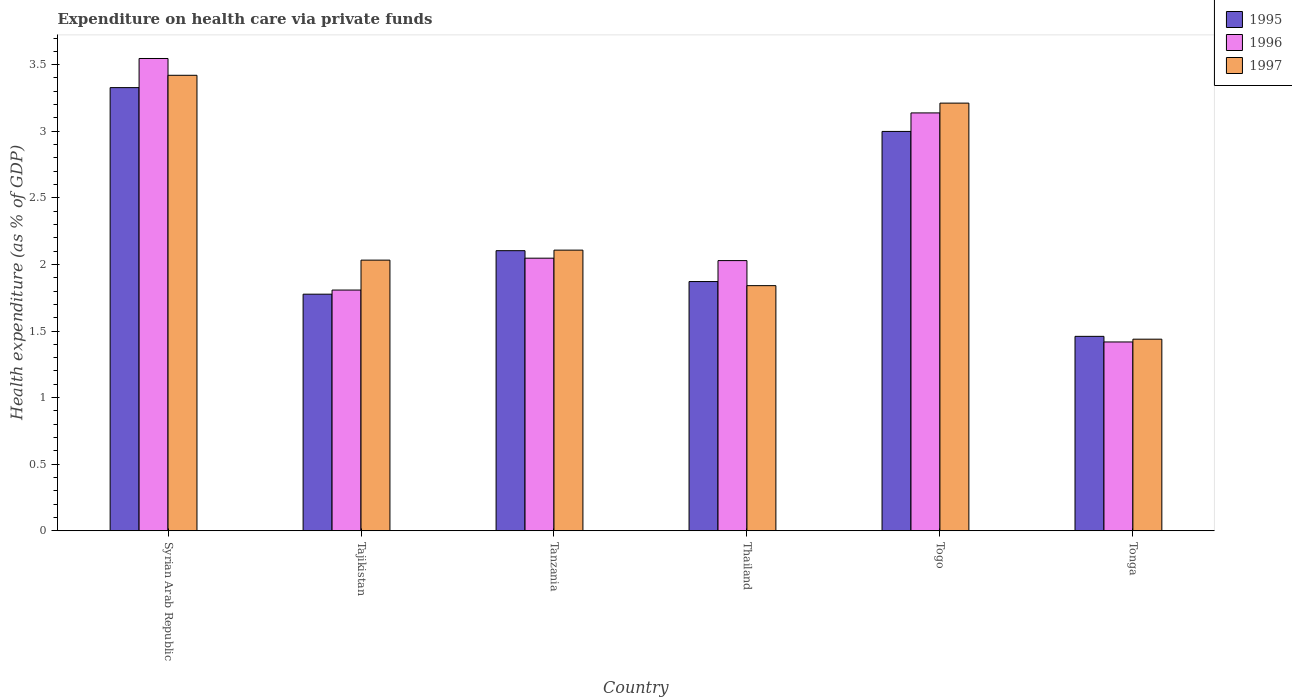Are the number of bars on each tick of the X-axis equal?
Your response must be concise. Yes. What is the label of the 2nd group of bars from the left?
Your response must be concise. Tajikistan. In how many cases, is the number of bars for a given country not equal to the number of legend labels?
Keep it short and to the point. 0. What is the expenditure made on health care in 1995 in Thailand?
Offer a very short reply. 1.87. Across all countries, what is the maximum expenditure made on health care in 1997?
Keep it short and to the point. 3.42. Across all countries, what is the minimum expenditure made on health care in 1995?
Your response must be concise. 1.46. In which country was the expenditure made on health care in 1995 maximum?
Provide a succinct answer. Syrian Arab Republic. In which country was the expenditure made on health care in 1995 minimum?
Offer a very short reply. Tonga. What is the total expenditure made on health care in 1995 in the graph?
Provide a succinct answer. 13.54. What is the difference between the expenditure made on health care in 1996 in Tanzania and that in Tonga?
Give a very brief answer. 0.63. What is the difference between the expenditure made on health care in 1995 in Tonga and the expenditure made on health care in 1996 in Togo?
Keep it short and to the point. -1.68. What is the average expenditure made on health care in 1996 per country?
Make the answer very short. 2.33. What is the difference between the expenditure made on health care of/in 1996 and expenditure made on health care of/in 1997 in Thailand?
Your answer should be very brief. 0.19. In how many countries, is the expenditure made on health care in 1996 greater than 2.6 %?
Provide a succinct answer. 2. What is the ratio of the expenditure made on health care in 1995 in Syrian Arab Republic to that in Tajikistan?
Your response must be concise. 1.87. What is the difference between the highest and the second highest expenditure made on health care in 1995?
Provide a short and direct response. -0.33. What is the difference between the highest and the lowest expenditure made on health care in 1995?
Give a very brief answer. 1.87. In how many countries, is the expenditure made on health care in 1997 greater than the average expenditure made on health care in 1997 taken over all countries?
Keep it short and to the point. 2. Is the sum of the expenditure made on health care in 1997 in Syrian Arab Republic and Togo greater than the maximum expenditure made on health care in 1995 across all countries?
Provide a succinct answer. Yes. What does the 2nd bar from the right in Tonga represents?
Your response must be concise. 1996. Is it the case that in every country, the sum of the expenditure made on health care in 1995 and expenditure made on health care in 1997 is greater than the expenditure made on health care in 1996?
Provide a succinct answer. Yes. How many bars are there?
Ensure brevity in your answer.  18. How many countries are there in the graph?
Offer a very short reply. 6. Are the values on the major ticks of Y-axis written in scientific E-notation?
Ensure brevity in your answer.  No. Does the graph contain any zero values?
Offer a very short reply. No. Does the graph contain grids?
Your answer should be compact. No. How many legend labels are there?
Give a very brief answer. 3. How are the legend labels stacked?
Provide a short and direct response. Vertical. What is the title of the graph?
Provide a succinct answer. Expenditure on health care via private funds. What is the label or title of the Y-axis?
Ensure brevity in your answer.  Health expenditure (as % of GDP). What is the Health expenditure (as % of GDP) of 1995 in Syrian Arab Republic?
Keep it short and to the point. 3.33. What is the Health expenditure (as % of GDP) of 1996 in Syrian Arab Republic?
Give a very brief answer. 3.55. What is the Health expenditure (as % of GDP) of 1997 in Syrian Arab Republic?
Offer a terse response. 3.42. What is the Health expenditure (as % of GDP) in 1995 in Tajikistan?
Offer a terse response. 1.78. What is the Health expenditure (as % of GDP) in 1996 in Tajikistan?
Your answer should be very brief. 1.81. What is the Health expenditure (as % of GDP) of 1997 in Tajikistan?
Provide a succinct answer. 2.03. What is the Health expenditure (as % of GDP) in 1995 in Tanzania?
Ensure brevity in your answer.  2.1. What is the Health expenditure (as % of GDP) in 1996 in Tanzania?
Keep it short and to the point. 2.05. What is the Health expenditure (as % of GDP) in 1997 in Tanzania?
Offer a very short reply. 2.11. What is the Health expenditure (as % of GDP) of 1995 in Thailand?
Provide a short and direct response. 1.87. What is the Health expenditure (as % of GDP) of 1996 in Thailand?
Your answer should be very brief. 2.03. What is the Health expenditure (as % of GDP) of 1997 in Thailand?
Ensure brevity in your answer.  1.84. What is the Health expenditure (as % of GDP) in 1995 in Togo?
Offer a terse response. 3. What is the Health expenditure (as % of GDP) in 1996 in Togo?
Make the answer very short. 3.14. What is the Health expenditure (as % of GDP) of 1997 in Togo?
Ensure brevity in your answer.  3.21. What is the Health expenditure (as % of GDP) in 1995 in Tonga?
Your answer should be compact. 1.46. What is the Health expenditure (as % of GDP) of 1996 in Tonga?
Offer a very short reply. 1.42. What is the Health expenditure (as % of GDP) in 1997 in Tonga?
Your answer should be compact. 1.44. Across all countries, what is the maximum Health expenditure (as % of GDP) of 1995?
Give a very brief answer. 3.33. Across all countries, what is the maximum Health expenditure (as % of GDP) of 1996?
Your answer should be very brief. 3.55. Across all countries, what is the maximum Health expenditure (as % of GDP) of 1997?
Give a very brief answer. 3.42. Across all countries, what is the minimum Health expenditure (as % of GDP) in 1995?
Ensure brevity in your answer.  1.46. Across all countries, what is the minimum Health expenditure (as % of GDP) in 1996?
Your response must be concise. 1.42. Across all countries, what is the minimum Health expenditure (as % of GDP) of 1997?
Ensure brevity in your answer.  1.44. What is the total Health expenditure (as % of GDP) of 1995 in the graph?
Give a very brief answer. 13.54. What is the total Health expenditure (as % of GDP) in 1996 in the graph?
Provide a succinct answer. 13.99. What is the total Health expenditure (as % of GDP) of 1997 in the graph?
Keep it short and to the point. 14.05. What is the difference between the Health expenditure (as % of GDP) in 1995 in Syrian Arab Republic and that in Tajikistan?
Your answer should be compact. 1.55. What is the difference between the Health expenditure (as % of GDP) of 1996 in Syrian Arab Republic and that in Tajikistan?
Your response must be concise. 1.74. What is the difference between the Health expenditure (as % of GDP) of 1997 in Syrian Arab Republic and that in Tajikistan?
Provide a succinct answer. 1.39. What is the difference between the Health expenditure (as % of GDP) of 1995 in Syrian Arab Republic and that in Tanzania?
Give a very brief answer. 1.22. What is the difference between the Health expenditure (as % of GDP) in 1996 in Syrian Arab Republic and that in Tanzania?
Make the answer very short. 1.5. What is the difference between the Health expenditure (as % of GDP) in 1997 in Syrian Arab Republic and that in Tanzania?
Offer a terse response. 1.31. What is the difference between the Health expenditure (as % of GDP) of 1995 in Syrian Arab Republic and that in Thailand?
Give a very brief answer. 1.46. What is the difference between the Health expenditure (as % of GDP) in 1996 in Syrian Arab Republic and that in Thailand?
Offer a terse response. 1.52. What is the difference between the Health expenditure (as % of GDP) in 1997 in Syrian Arab Republic and that in Thailand?
Your answer should be very brief. 1.58. What is the difference between the Health expenditure (as % of GDP) of 1995 in Syrian Arab Republic and that in Togo?
Make the answer very short. 0.33. What is the difference between the Health expenditure (as % of GDP) of 1996 in Syrian Arab Republic and that in Togo?
Ensure brevity in your answer.  0.41. What is the difference between the Health expenditure (as % of GDP) of 1997 in Syrian Arab Republic and that in Togo?
Provide a succinct answer. 0.21. What is the difference between the Health expenditure (as % of GDP) in 1995 in Syrian Arab Republic and that in Tonga?
Provide a short and direct response. 1.87. What is the difference between the Health expenditure (as % of GDP) in 1996 in Syrian Arab Republic and that in Tonga?
Provide a succinct answer. 2.13. What is the difference between the Health expenditure (as % of GDP) of 1997 in Syrian Arab Republic and that in Tonga?
Keep it short and to the point. 1.98. What is the difference between the Health expenditure (as % of GDP) in 1995 in Tajikistan and that in Tanzania?
Offer a terse response. -0.33. What is the difference between the Health expenditure (as % of GDP) in 1996 in Tajikistan and that in Tanzania?
Provide a succinct answer. -0.24. What is the difference between the Health expenditure (as % of GDP) of 1997 in Tajikistan and that in Tanzania?
Ensure brevity in your answer.  -0.08. What is the difference between the Health expenditure (as % of GDP) in 1995 in Tajikistan and that in Thailand?
Provide a short and direct response. -0.09. What is the difference between the Health expenditure (as % of GDP) of 1996 in Tajikistan and that in Thailand?
Your answer should be compact. -0.22. What is the difference between the Health expenditure (as % of GDP) in 1997 in Tajikistan and that in Thailand?
Offer a very short reply. 0.19. What is the difference between the Health expenditure (as % of GDP) in 1995 in Tajikistan and that in Togo?
Make the answer very short. -1.22. What is the difference between the Health expenditure (as % of GDP) in 1996 in Tajikistan and that in Togo?
Your answer should be very brief. -1.33. What is the difference between the Health expenditure (as % of GDP) in 1997 in Tajikistan and that in Togo?
Ensure brevity in your answer.  -1.18. What is the difference between the Health expenditure (as % of GDP) of 1995 in Tajikistan and that in Tonga?
Provide a short and direct response. 0.32. What is the difference between the Health expenditure (as % of GDP) in 1996 in Tajikistan and that in Tonga?
Your answer should be very brief. 0.39. What is the difference between the Health expenditure (as % of GDP) of 1997 in Tajikistan and that in Tonga?
Your answer should be compact. 0.59. What is the difference between the Health expenditure (as % of GDP) in 1995 in Tanzania and that in Thailand?
Provide a short and direct response. 0.23. What is the difference between the Health expenditure (as % of GDP) of 1996 in Tanzania and that in Thailand?
Make the answer very short. 0.02. What is the difference between the Health expenditure (as % of GDP) of 1997 in Tanzania and that in Thailand?
Your answer should be very brief. 0.27. What is the difference between the Health expenditure (as % of GDP) in 1995 in Tanzania and that in Togo?
Keep it short and to the point. -0.9. What is the difference between the Health expenditure (as % of GDP) in 1996 in Tanzania and that in Togo?
Ensure brevity in your answer.  -1.09. What is the difference between the Health expenditure (as % of GDP) in 1997 in Tanzania and that in Togo?
Provide a succinct answer. -1.1. What is the difference between the Health expenditure (as % of GDP) of 1995 in Tanzania and that in Tonga?
Keep it short and to the point. 0.64. What is the difference between the Health expenditure (as % of GDP) in 1996 in Tanzania and that in Tonga?
Provide a short and direct response. 0.63. What is the difference between the Health expenditure (as % of GDP) in 1997 in Tanzania and that in Tonga?
Offer a very short reply. 0.67. What is the difference between the Health expenditure (as % of GDP) in 1995 in Thailand and that in Togo?
Make the answer very short. -1.13. What is the difference between the Health expenditure (as % of GDP) in 1996 in Thailand and that in Togo?
Your answer should be very brief. -1.11. What is the difference between the Health expenditure (as % of GDP) in 1997 in Thailand and that in Togo?
Make the answer very short. -1.37. What is the difference between the Health expenditure (as % of GDP) in 1995 in Thailand and that in Tonga?
Provide a short and direct response. 0.41. What is the difference between the Health expenditure (as % of GDP) in 1996 in Thailand and that in Tonga?
Make the answer very short. 0.61. What is the difference between the Health expenditure (as % of GDP) in 1997 in Thailand and that in Tonga?
Ensure brevity in your answer.  0.4. What is the difference between the Health expenditure (as % of GDP) in 1995 in Togo and that in Tonga?
Keep it short and to the point. 1.54. What is the difference between the Health expenditure (as % of GDP) in 1996 in Togo and that in Tonga?
Make the answer very short. 1.72. What is the difference between the Health expenditure (as % of GDP) of 1997 in Togo and that in Tonga?
Your answer should be compact. 1.77. What is the difference between the Health expenditure (as % of GDP) in 1995 in Syrian Arab Republic and the Health expenditure (as % of GDP) in 1996 in Tajikistan?
Your answer should be very brief. 1.52. What is the difference between the Health expenditure (as % of GDP) of 1995 in Syrian Arab Republic and the Health expenditure (as % of GDP) of 1997 in Tajikistan?
Offer a very short reply. 1.3. What is the difference between the Health expenditure (as % of GDP) in 1996 in Syrian Arab Republic and the Health expenditure (as % of GDP) in 1997 in Tajikistan?
Your response must be concise. 1.51. What is the difference between the Health expenditure (as % of GDP) of 1995 in Syrian Arab Republic and the Health expenditure (as % of GDP) of 1996 in Tanzania?
Your response must be concise. 1.28. What is the difference between the Health expenditure (as % of GDP) in 1995 in Syrian Arab Republic and the Health expenditure (as % of GDP) in 1997 in Tanzania?
Give a very brief answer. 1.22. What is the difference between the Health expenditure (as % of GDP) in 1996 in Syrian Arab Republic and the Health expenditure (as % of GDP) in 1997 in Tanzania?
Offer a very short reply. 1.44. What is the difference between the Health expenditure (as % of GDP) in 1995 in Syrian Arab Republic and the Health expenditure (as % of GDP) in 1996 in Thailand?
Provide a succinct answer. 1.3. What is the difference between the Health expenditure (as % of GDP) of 1995 in Syrian Arab Republic and the Health expenditure (as % of GDP) of 1997 in Thailand?
Your response must be concise. 1.49. What is the difference between the Health expenditure (as % of GDP) in 1996 in Syrian Arab Republic and the Health expenditure (as % of GDP) in 1997 in Thailand?
Provide a succinct answer. 1.71. What is the difference between the Health expenditure (as % of GDP) in 1995 in Syrian Arab Republic and the Health expenditure (as % of GDP) in 1996 in Togo?
Your response must be concise. 0.19. What is the difference between the Health expenditure (as % of GDP) in 1995 in Syrian Arab Republic and the Health expenditure (as % of GDP) in 1997 in Togo?
Make the answer very short. 0.12. What is the difference between the Health expenditure (as % of GDP) in 1996 in Syrian Arab Republic and the Health expenditure (as % of GDP) in 1997 in Togo?
Provide a succinct answer. 0.34. What is the difference between the Health expenditure (as % of GDP) of 1995 in Syrian Arab Republic and the Health expenditure (as % of GDP) of 1996 in Tonga?
Make the answer very short. 1.91. What is the difference between the Health expenditure (as % of GDP) of 1995 in Syrian Arab Republic and the Health expenditure (as % of GDP) of 1997 in Tonga?
Provide a short and direct response. 1.89. What is the difference between the Health expenditure (as % of GDP) in 1996 in Syrian Arab Republic and the Health expenditure (as % of GDP) in 1997 in Tonga?
Your answer should be very brief. 2.11. What is the difference between the Health expenditure (as % of GDP) in 1995 in Tajikistan and the Health expenditure (as % of GDP) in 1996 in Tanzania?
Your response must be concise. -0.27. What is the difference between the Health expenditure (as % of GDP) in 1995 in Tajikistan and the Health expenditure (as % of GDP) in 1997 in Tanzania?
Offer a terse response. -0.33. What is the difference between the Health expenditure (as % of GDP) of 1996 in Tajikistan and the Health expenditure (as % of GDP) of 1997 in Tanzania?
Your response must be concise. -0.3. What is the difference between the Health expenditure (as % of GDP) of 1995 in Tajikistan and the Health expenditure (as % of GDP) of 1996 in Thailand?
Keep it short and to the point. -0.25. What is the difference between the Health expenditure (as % of GDP) in 1995 in Tajikistan and the Health expenditure (as % of GDP) in 1997 in Thailand?
Offer a very short reply. -0.06. What is the difference between the Health expenditure (as % of GDP) of 1996 in Tajikistan and the Health expenditure (as % of GDP) of 1997 in Thailand?
Provide a succinct answer. -0.03. What is the difference between the Health expenditure (as % of GDP) of 1995 in Tajikistan and the Health expenditure (as % of GDP) of 1996 in Togo?
Provide a succinct answer. -1.36. What is the difference between the Health expenditure (as % of GDP) of 1995 in Tajikistan and the Health expenditure (as % of GDP) of 1997 in Togo?
Your answer should be very brief. -1.43. What is the difference between the Health expenditure (as % of GDP) of 1996 in Tajikistan and the Health expenditure (as % of GDP) of 1997 in Togo?
Your answer should be very brief. -1.4. What is the difference between the Health expenditure (as % of GDP) of 1995 in Tajikistan and the Health expenditure (as % of GDP) of 1996 in Tonga?
Make the answer very short. 0.36. What is the difference between the Health expenditure (as % of GDP) in 1995 in Tajikistan and the Health expenditure (as % of GDP) in 1997 in Tonga?
Give a very brief answer. 0.34. What is the difference between the Health expenditure (as % of GDP) in 1996 in Tajikistan and the Health expenditure (as % of GDP) in 1997 in Tonga?
Your response must be concise. 0.37. What is the difference between the Health expenditure (as % of GDP) in 1995 in Tanzania and the Health expenditure (as % of GDP) in 1996 in Thailand?
Give a very brief answer. 0.07. What is the difference between the Health expenditure (as % of GDP) of 1995 in Tanzania and the Health expenditure (as % of GDP) of 1997 in Thailand?
Ensure brevity in your answer.  0.26. What is the difference between the Health expenditure (as % of GDP) in 1996 in Tanzania and the Health expenditure (as % of GDP) in 1997 in Thailand?
Your answer should be compact. 0.21. What is the difference between the Health expenditure (as % of GDP) of 1995 in Tanzania and the Health expenditure (as % of GDP) of 1996 in Togo?
Your answer should be very brief. -1.03. What is the difference between the Health expenditure (as % of GDP) of 1995 in Tanzania and the Health expenditure (as % of GDP) of 1997 in Togo?
Provide a succinct answer. -1.11. What is the difference between the Health expenditure (as % of GDP) of 1996 in Tanzania and the Health expenditure (as % of GDP) of 1997 in Togo?
Ensure brevity in your answer.  -1.16. What is the difference between the Health expenditure (as % of GDP) of 1995 in Tanzania and the Health expenditure (as % of GDP) of 1996 in Tonga?
Provide a short and direct response. 0.69. What is the difference between the Health expenditure (as % of GDP) of 1995 in Tanzania and the Health expenditure (as % of GDP) of 1997 in Tonga?
Ensure brevity in your answer.  0.66. What is the difference between the Health expenditure (as % of GDP) in 1996 in Tanzania and the Health expenditure (as % of GDP) in 1997 in Tonga?
Give a very brief answer. 0.61. What is the difference between the Health expenditure (as % of GDP) in 1995 in Thailand and the Health expenditure (as % of GDP) in 1996 in Togo?
Your answer should be very brief. -1.27. What is the difference between the Health expenditure (as % of GDP) of 1995 in Thailand and the Health expenditure (as % of GDP) of 1997 in Togo?
Give a very brief answer. -1.34. What is the difference between the Health expenditure (as % of GDP) in 1996 in Thailand and the Health expenditure (as % of GDP) in 1997 in Togo?
Provide a short and direct response. -1.18. What is the difference between the Health expenditure (as % of GDP) in 1995 in Thailand and the Health expenditure (as % of GDP) in 1996 in Tonga?
Provide a succinct answer. 0.45. What is the difference between the Health expenditure (as % of GDP) in 1995 in Thailand and the Health expenditure (as % of GDP) in 1997 in Tonga?
Provide a short and direct response. 0.43. What is the difference between the Health expenditure (as % of GDP) in 1996 in Thailand and the Health expenditure (as % of GDP) in 1997 in Tonga?
Give a very brief answer. 0.59. What is the difference between the Health expenditure (as % of GDP) of 1995 in Togo and the Health expenditure (as % of GDP) of 1996 in Tonga?
Provide a short and direct response. 1.58. What is the difference between the Health expenditure (as % of GDP) of 1995 in Togo and the Health expenditure (as % of GDP) of 1997 in Tonga?
Provide a short and direct response. 1.56. What is the difference between the Health expenditure (as % of GDP) in 1996 in Togo and the Health expenditure (as % of GDP) in 1997 in Tonga?
Your response must be concise. 1.7. What is the average Health expenditure (as % of GDP) in 1995 per country?
Make the answer very short. 2.26. What is the average Health expenditure (as % of GDP) of 1996 per country?
Make the answer very short. 2.33. What is the average Health expenditure (as % of GDP) in 1997 per country?
Ensure brevity in your answer.  2.34. What is the difference between the Health expenditure (as % of GDP) of 1995 and Health expenditure (as % of GDP) of 1996 in Syrian Arab Republic?
Your answer should be very brief. -0.22. What is the difference between the Health expenditure (as % of GDP) in 1995 and Health expenditure (as % of GDP) in 1997 in Syrian Arab Republic?
Ensure brevity in your answer.  -0.09. What is the difference between the Health expenditure (as % of GDP) in 1996 and Health expenditure (as % of GDP) in 1997 in Syrian Arab Republic?
Make the answer very short. 0.13. What is the difference between the Health expenditure (as % of GDP) in 1995 and Health expenditure (as % of GDP) in 1996 in Tajikistan?
Your response must be concise. -0.03. What is the difference between the Health expenditure (as % of GDP) of 1995 and Health expenditure (as % of GDP) of 1997 in Tajikistan?
Your response must be concise. -0.26. What is the difference between the Health expenditure (as % of GDP) of 1996 and Health expenditure (as % of GDP) of 1997 in Tajikistan?
Offer a very short reply. -0.22. What is the difference between the Health expenditure (as % of GDP) in 1995 and Health expenditure (as % of GDP) in 1996 in Tanzania?
Provide a succinct answer. 0.06. What is the difference between the Health expenditure (as % of GDP) of 1995 and Health expenditure (as % of GDP) of 1997 in Tanzania?
Your answer should be very brief. -0. What is the difference between the Health expenditure (as % of GDP) in 1996 and Health expenditure (as % of GDP) in 1997 in Tanzania?
Give a very brief answer. -0.06. What is the difference between the Health expenditure (as % of GDP) of 1995 and Health expenditure (as % of GDP) of 1996 in Thailand?
Your answer should be very brief. -0.16. What is the difference between the Health expenditure (as % of GDP) in 1995 and Health expenditure (as % of GDP) in 1997 in Thailand?
Your response must be concise. 0.03. What is the difference between the Health expenditure (as % of GDP) of 1996 and Health expenditure (as % of GDP) of 1997 in Thailand?
Your response must be concise. 0.19. What is the difference between the Health expenditure (as % of GDP) of 1995 and Health expenditure (as % of GDP) of 1996 in Togo?
Provide a succinct answer. -0.14. What is the difference between the Health expenditure (as % of GDP) in 1995 and Health expenditure (as % of GDP) in 1997 in Togo?
Your response must be concise. -0.21. What is the difference between the Health expenditure (as % of GDP) of 1996 and Health expenditure (as % of GDP) of 1997 in Togo?
Provide a short and direct response. -0.07. What is the difference between the Health expenditure (as % of GDP) of 1995 and Health expenditure (as % of GDP) of 1996 in Tonga?
Provide a short and direct response. 0.04. What is the difference between the Health expenditure (as % of GDP) in 1995 and Health expenditure (as % of GDP) in 1997 in Tonga?
Offer a very short reply. 0.02. What is the difference between the Health expenditure (as % of GDP) in 1996 and Health expenditure (as % of GDP) in 1997 in Tonga?
Offer a terse response. -0.02. What is the ratio of the Health expenditure (as % of GDP) of 1995 in Syrian Arab Republic to that in Tajikistan?
Provide a short and direct response. 1.87. What is the ratio of the Health expenditure (as % of GDP) in 1996 in Syrian Arab Republic to that in Tajikistan?
Give a very brief answer. 1.96. What is the ratio of the Health expenditure (as % of GDP) of 1997 in Syrian Arab Republic to that in Tajikistan?
Keep it short and to the point. 1.68. What is the ratio of the Health expenditure (as % of GDP) of 1995 in Syrian Arab Republic to that in Tanzania?
Make the answer very short. 1.58. What is the ratio of the Health expenditure (as % of GDP) in 1996 in Syrian Arab Republic to that in Tanzania?
Make the answer very short. 1.73. What is the ratio of the Health expenditure (as % of GDP) in 1997 in Syrian Arab Republic to that in Tanzania?
Make the answer very short. 1.62. What is the ratio of the Health expenditure (as % of GDP) in 1995 in Syrian Arab Republic to that in Thailand?
Your answer should be very brief. 1.78. What is the ratio of the Health expenditure (as % of GDP) in 1996 in Syrian Arab Republic to that in Thailand?
Make the answer very short. 1.75. What is the ratio of the Health expenditure (as % of GDP) in 1997 in Syrian Arab Republic to that in Thailand?
Give a very brief answer. 1.86. What is the ratio of the Health expenditure (as % of GDP) of 1995 in Syrian Arab Republic to that in Togo?
Make the answer very short. 1.11. What is the ratio of the Health expenditure (as % of GDP) in 1996 in Syrian Arab Republic to that in Togo?
Provide a succinct answer. 1.13. What is the ratio of the Health expenditure (as % of GDP) of 1997 in Syrian Arab Republic to that in Togo?
Keep it short and to the point. 1.07. What is the ratio of the Health expenditure (as % of GDP) of 1995 in Syrian Arab Republic to that in Tonga?
Provide a succinct answer. 2.28. What is the ratio of the Health expenditure (as % of GDP) of 1996 in Syrian Arab Republic to that in Tonga?
Offer a very short reply. 2.5. What is the ratio of the Health expenditure (as % of GDP) in 1997 in Syrian Arab Republic to that in Tonga?
Keep it short and to the point. 2.38. What is the ratio of the Health expenditure (as % of GDP) of 1995 in Tajikistan to that in Tanzania?
Ensure brevity in your answer.  0.84. What is the ratio of the Health expenditure (as % of GDP) of 1996 in Tajikistan to that in Tanzania?
Ensure brevity in your answer.  0.88. What is the ratio of the Health expenditure (as % of GDP) of 1997 in Tajikistan to that in Tanzania?
Your answer should be compact. 0.96. What is the ratio of the Health expenditure (as % of GDP) in 1995 in Tajikistan to that in Thailand?
Keep it short and to the point. 0.95. What is the ratio of the Health expenditure (as % of GDP) of 1996 in Tajikistan to that in Thailand?
Your response must be concise. 0.89. What is the ratio of the Health expenditure (as % of GDP) of 1997 in Tajikistan to that in Thailand?
Your response must be concise. 1.1. What is the ratio of the Health expenditure (as % of GDP) in 1995 in Tajikistan to that in Togo?
Provide a short and direct response. 0.59. What is the ratio of the Health expenditure (as % of GDP) in 1996 in Tajikistan to that in Togo?
Provide a short and direct response. 0.58. What is the ratio of the Health expenditure (as % of GDP) in 1997 in Tajikistan to that in Togo?
Ensure brevity in your answer.  0.63. What is the ratio of the Health expenditure (as % of GDP) in 1995 in Tajikistan to that in Tonga?
Make the answer very short. 1.22. What is the ratio of the Health expenditure (as % of GDP) of 1996 in Tajikistan to that in Tonga?
Provide a succinct answer. 1.27. What is the ratio of the Health expenditure (as % of GDP) of 1997 in Tajikistan to that in Tonga?
Ensure brevity in your answer.  1.41. What is the ratio of the Health expenditure (as % of GDP) of 1995 in Tanzania to that in Thailand?
Provide a succinct answer. 1.12. What is the ratio of the Health expenditure (as % of GDP) of 1996 in Tanzania to that in Thailand?
Ensure brevity in your answer.  1.01. What is the ratio of the Health expenditure (as % of GDP) of 1997 in Tanzania to that in Thailand?
Give a very brief answer. 1.14. What is the ratio of the Health expenditure (as % of GDP) in 1995 in Tanzania to that in Togo?
Your response must be concise. 0.7. What is the ratio of the Health expenditure (as % of GDP) of 1996 in Tanzania to that in Togo?
Offer a very short reply. 0.65. What is the ratio of the Health expenditure (as % of GDP) of 1997 in Tanzania to that in Togo?
Offer a very short reply. 0.66. What is the ratio of the Health expenditure (as % of GDP) in 1995 in Tanzania to that in Tonga?
Keep it short and to the point. 1.44. What is the ratio of the Health expenditure (as % of GDP) of 1996 in Tanzania to that in Tonga?
Provide a short and direct response. 1.44. What is the ratio of the Health expenditure (as % of GDP) of 1997 in Tanzania to that in Tonga?
Your response must be concise. 1.46. What is the ratio of the Health expenditure (as % of GDP) of 1995 in Thailand to that in Togo?
Give a very brief answer. 0.62. What is the ratio of the Health expenditure (as % of GDP) in 1996 in Thailand to that in Togo?
Give a very brief answer. 0.65. What is the ratio of the Health expenditure (as % of GDP) of 1997 in Thailand to that in Togo?
Give a very brief answer. 0.57. What is the ratio of the Health expenditure (as % of GDP) of 1995 in Thailand to that in Tonga?
Give a very brief answer. 1.28. What is the ratio of the Health expenditure (as % of GDP) in 1996 in Thailand to that in Tonga?
Offer a very short reply. 1.43. What is the ratio of the Health expenditure (as % of GDP) of 1997 in Thailand to that in Tonga?
Offer a very short reply. 1.28. What is the ratio of the Health expenditure (as % of GDP) in 1995 in Togo to that in Tonga?
Give a very brief answer. 2.05. What is the ratio of the Health expenditure (as % of GDP) in 1996 in Togo to that in Tonga?
Provide a short and direct response. 2.21. What is the ratio of the Health expenditure (as % of GDP) of 1997 in Togo to that in Tonga?
Your answer should be very brief. 2.23. What is the difference between the highest and the second highest Health expenditure (as % of GDP) in 1995?
Offer a very short reply. 0.33. What is the difference between the highest and the second highest Health expenditure (as % of GDP) of 1996?
Ensure brevity in your answer.  0.41. What is the difference between the highest and the second highest Health expenditure (as % of GDP) of 1997?
Your answer should be very brief. 0.21. What is the difference between the highest and the lowest Health expenditure (as % of GDP) of 1995?
Give a very brief answer. 1.87. What is the difference between the highest and the lowest Health expenditure (as % of GDP) in 1996?
Keep it short and to the point. 2.13. What is the difference between the highest and the lowest Health expenditure (as % of GDP) of 1997?
Provide a succinct answer. 1.98. 